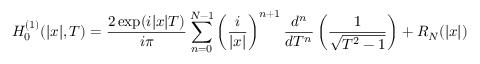<formula> <loc_0><loc_0><loc_500><loc_500>H _ { 0 } ^ { ( 1 ) } ( | x | , T ) = \frac { 2 \exp ( i | x | T ) } { i \pi } \sum _ { n = 0 } ^ { N - 1 } \left ( \frac { i } { | x | } \right ) ^ { n + 1 } \frac { d ^ { n } } { d T ^ { n } } \left ( \frac { 1 } { \sqrt { T ^ { 2 } - 1 } } \right ) + R _ { N } ( | x | )</formula> 